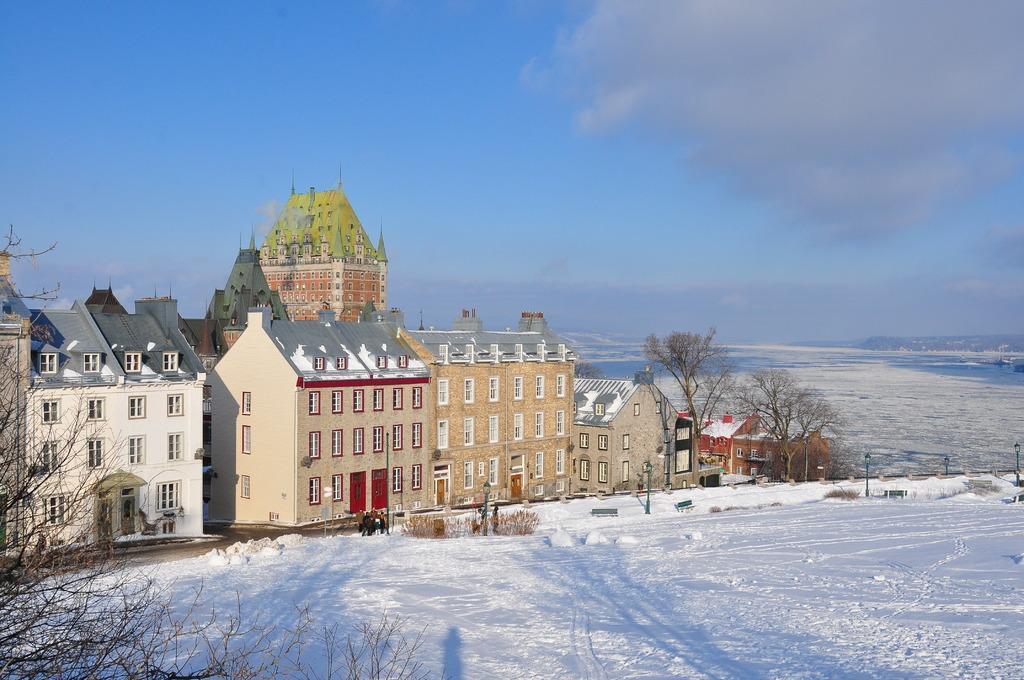Describe this image in one or two sentences. In this image we can see buildings with windows. There are trees. On the ground there is snow. In the background there is sky with clouds. 